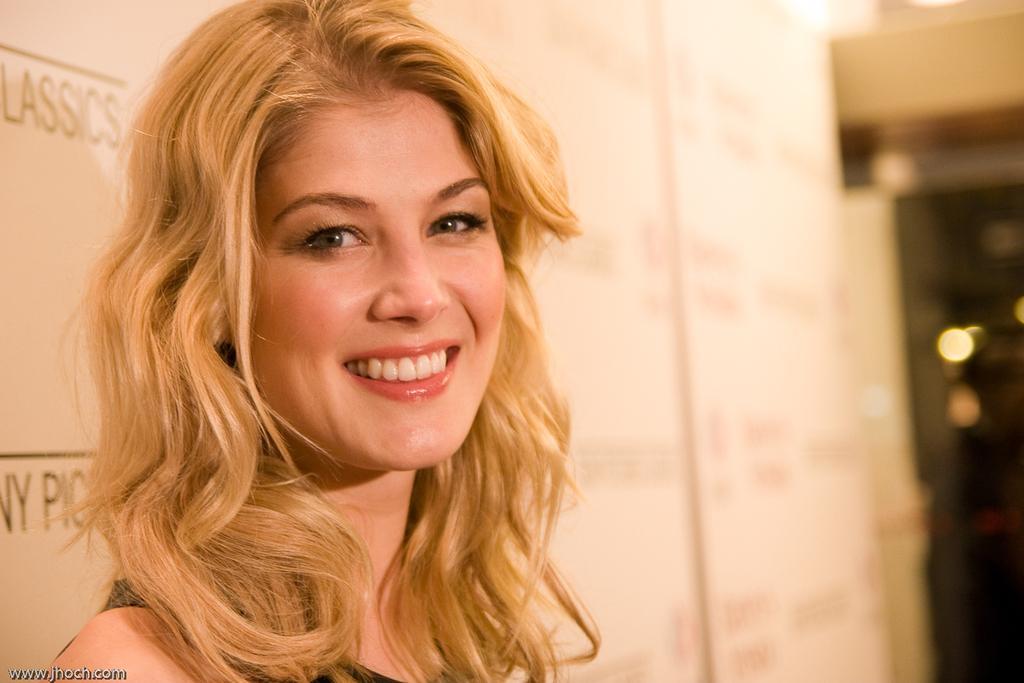Describe this image in one or two sentences. In this image we can see a woman. She is smiling. In the background, we can see white color banners with some text. 